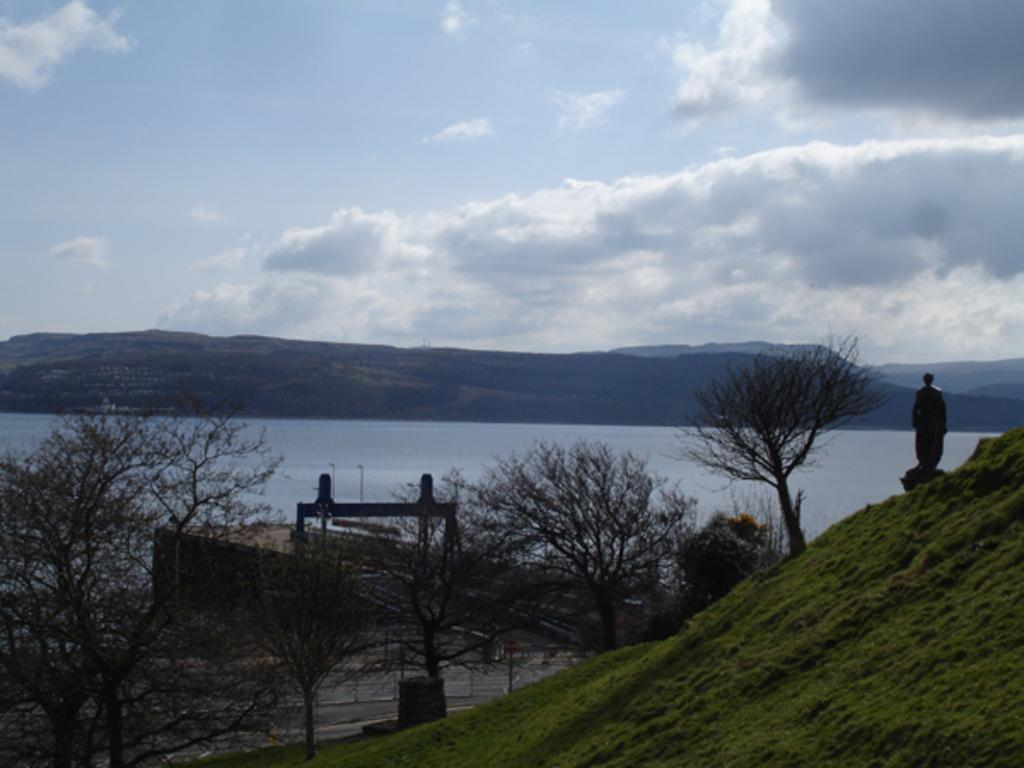What type of vegetation can be seen in the image? There are dry trees in the image. What man-made structure is present in the image? There is a bridge in the image. What other object can be seen in the image? There is a statue in the image. What natural features are visible in the image? There are mountains and water visible in the image. What is the color of the sky in the image? The sky is blue and white in color. Can you tell me what type of corn is growing near the bridge in the image? There is no corn present in the image; the vegetation consists of dry trees. Is there a lawyer guiding people across the bridge in the image? There is no lawyer or any indication of guiding people in the image; it only shows a bridge, dry trees, a statue, mountains, water, and a blue and white sky. 